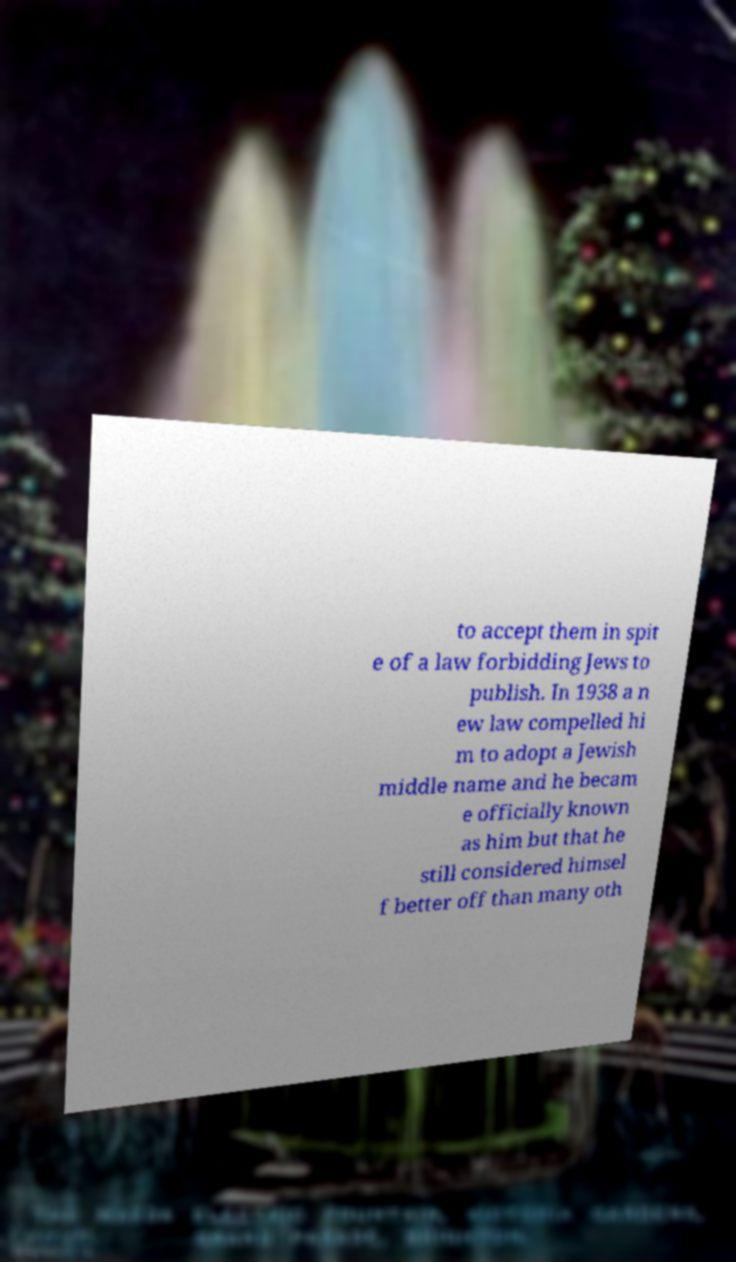Could you extract and type out the text from this image? to accept them in spit e of a law forbidding Jews to publish. In 1938 a n ew law compelled hi m to adopt a Jewish middle name and he becam e officially known as him but that he still considered himsel f better off than many oth 